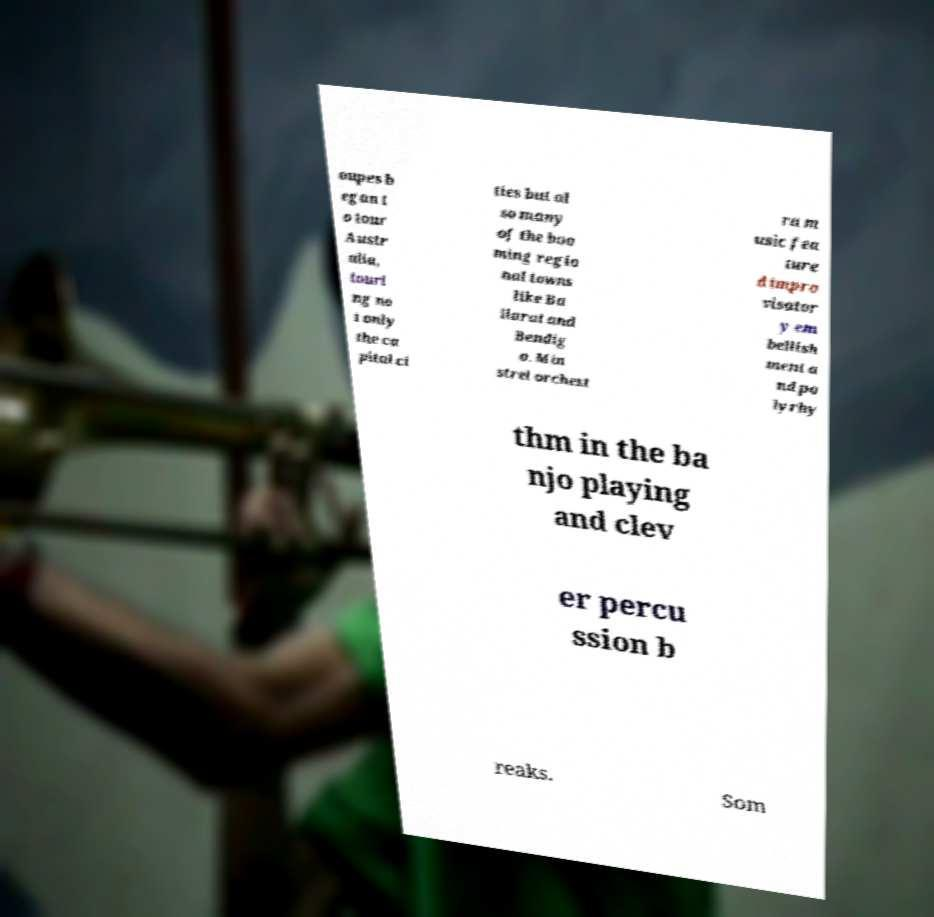Please identify and transcribe the text found in this image. oupes b egan t o tour Austr alia, touri ng no t only the ca pital ci ties but al so many of the boo ming regio nal towns like Ba llarat and Bendig o. Min strel orchest ra m usic fea ture d impro visator y em bellish ment a nd po lyrhy thm in the ba njo playing and clev er percu ssion b reaks. Som 